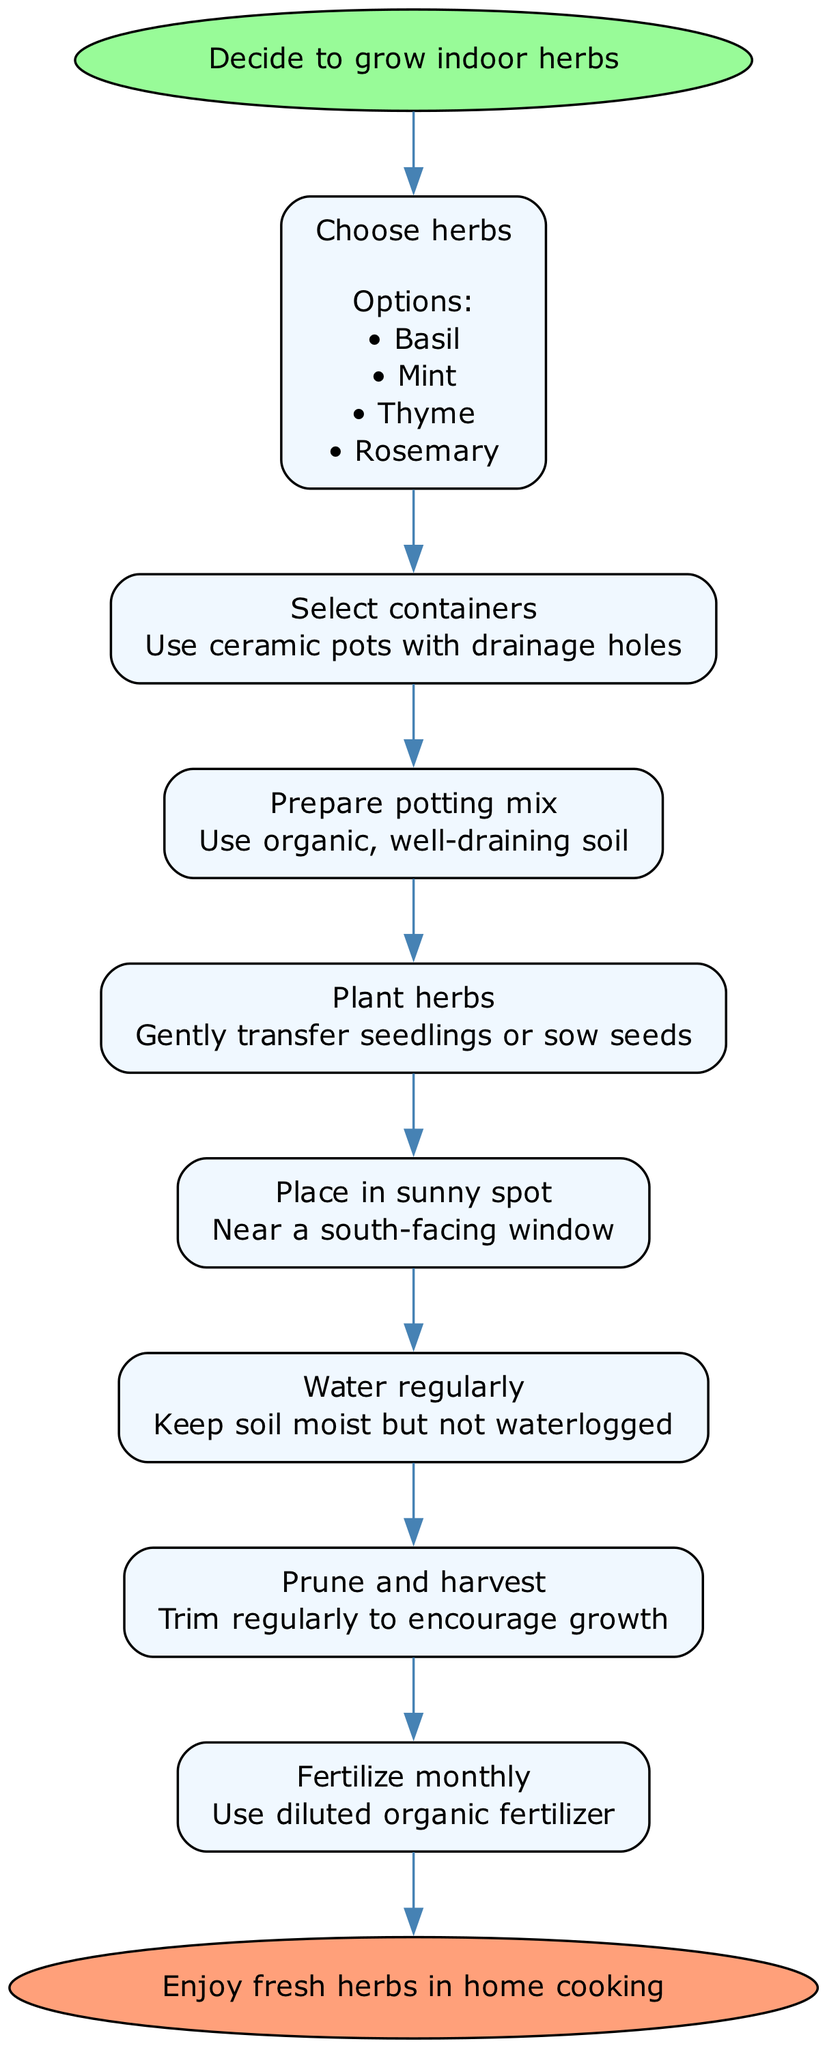What is the first step in the process? The diagram starts with the node labeled "Decide to grow indoor herbs," which is the initial action to take in the flow chart. Since it's the first node connected to the start, it defines the beginning of the gardening process.
Answer: Decide to grow indoor herbs How many herbs are suggested to choose from? In the "Choose herbs" step, there are four options listed: Basil, Mint, Thyme, and Rosemary. This provides a clear indication of the choices available for growing herbs.
Answer: Four What type of containers should be used? The step labeled "Select containers" specifies the use of "ceramic pots with drainage holes." This defines the required type of container for optimal growth conditions for the herbs.
Answer: Ceramic pots with drainage holes What does the "Prune and harvest" step involve? The description under the "Prune and harvest" step indicates that it entails "Trim regularly to encourage growth." This highlights the important process of maintaining the herbs to ensure they grow well.
Answer: Trim regularly to encourage growth What is the monthly maintenance action required? The "Fertilize monthly" step specifies using "diluted organic fertilizer" as the necessary action to maintain the health of the herbs in the garden. This indicates a clear requirement for regular fertilization.
Answer: Diluted organic fertilizer Which step directly follows "Plant herbs"? The diagram flows from the "Plant herbs" step to the "Place in sunny spot" step. This indicates that after planting, the next action required is to provide the right light conditions for the herbs.
Answer: Place in sunny spot How does the diagram indicate the end of the process? The last step in the flow is connected to the "Enjoy fresh herbs in home cooking" label, which is an ellipse indicating the conclusion of the gardening instructions by emphasizing the end goal of this effort.
Answer: Enjoy fresh herbs in home cooking 